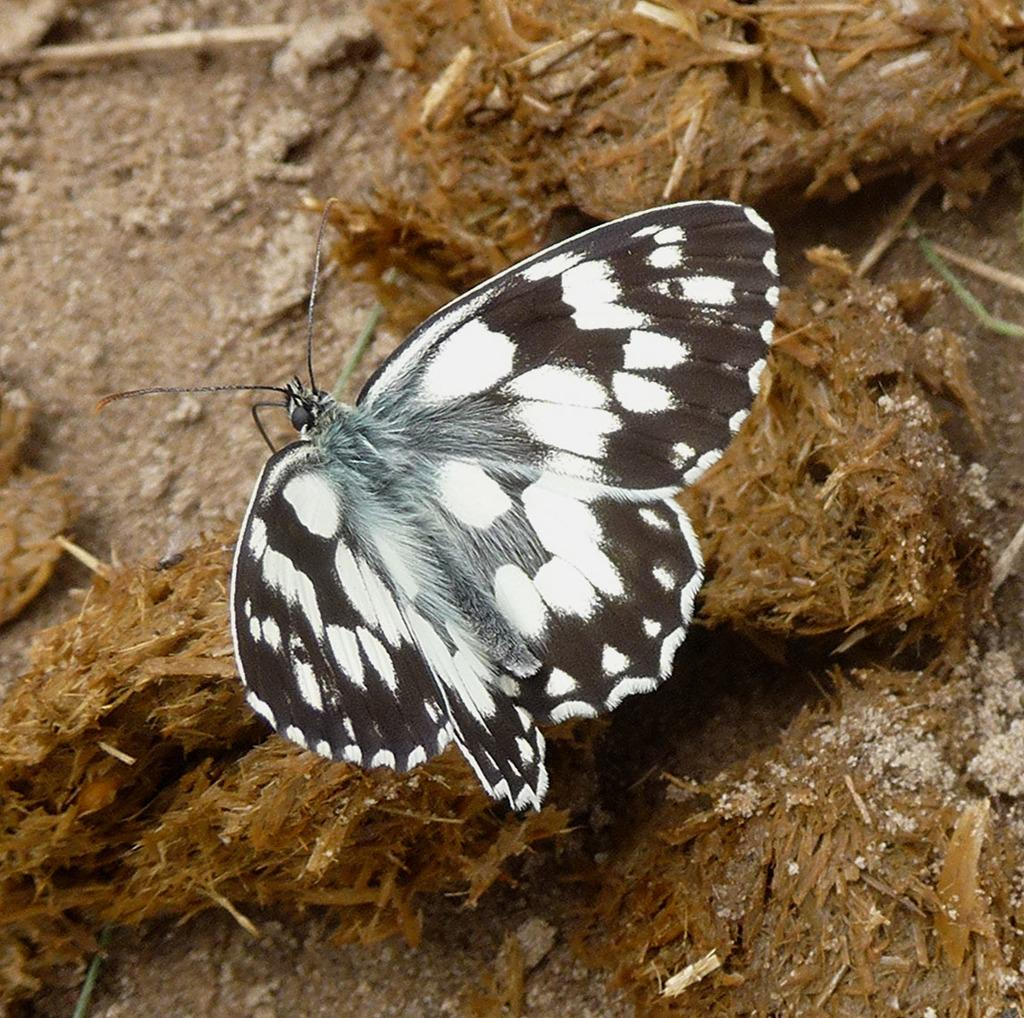What type of creature is present in the image? There is a butterfly in the image. What is the butterfly resting on in the image? The butterfly is on an object. Where is the object located in the image? The object is on the land. What shape is the butterfly twisting into in the image? The butterfly is not twisting into any shape in the image; it is simply resting on an object. How many girls are present in the image? There are no girls present in the image. 